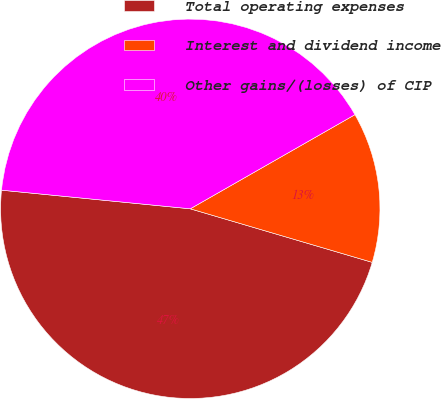Convert chart. <chart><loc_0><loc_0><loc_500><loc_500><pie_chart><fcel>Total operating expenses<fcel>Interest and dividend income<fcel>Other gains/(losses) of CIP<nl><fcel>47.01%<fcel>12.82%<fcel>40.17%<nl></chart> 